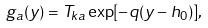Convert formula to latex. <formula><loc_0><loc_0><loc_500><loc_500>g _ { a } ( y ) = T _ { k a } \exp [ - q ( y - h _ { 0 } ) ] ,</formula> 